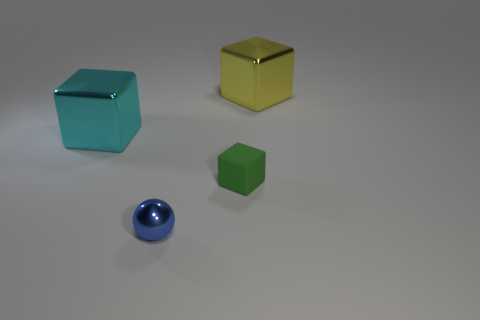Add 3 blue spheres. How many objects exist? 7 Subtract all cubes. How many objects are left? 1 Subtract all tiny green cubes. Subtract all brown shiny balls. How many objects are left? 3 Add 2 tiny metallic things. How many tiny metallic things are left? 3 Add 4 small blue things. How many small blue things exist? 5 Subtract 0 gray balls. How many objects are left? 4 